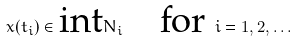<formula> <loc_0><loc_0><loc_500><loc_500>x ( t _ { i } ) \in \text {int} N _ { i } \quad \text {for } i = 1 , 2 , \dots</formula> 